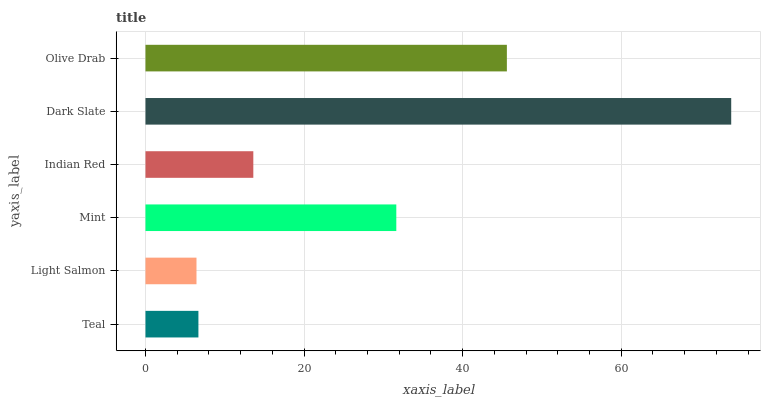Is Light Salmon the minimum?
Answer yes or no. Yes. Is Dark Slate the maximum?
Answer yes or no. Yes. Is Mint the minimum?
Answer yes or no. No. Is Mint the maximum?
Answer yes or no. No. Is Mint greater than Light Salmon?
Answer yes or no. Yes. Is Light Salmon less than Mint?
Answer yes or no. Yes. Is Light Salmon greater than Mint?
Answer yes or no. No. Is Mint less than Light Salmon?
Answer yes or no. No. Is Mint the high median?
Answer yes or no. Yes. Is Indian Red the low median?
Answer yes or no. Yes. Is Indian Red the high median?
Answer yes or no. No. Is Dark Slate the low median?
Answer yes or no. No. 